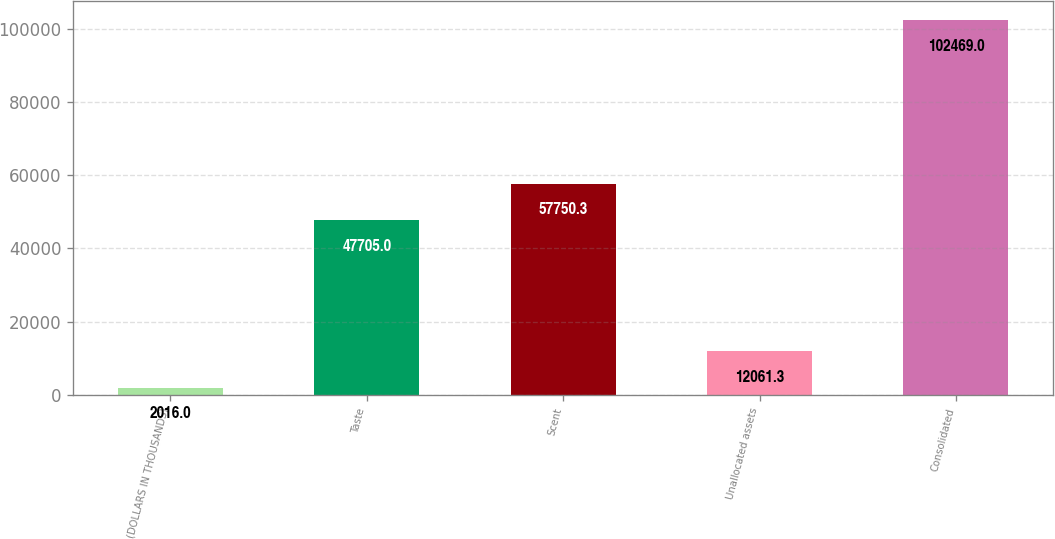<chart> <loc_0><loc_0><loc_500><loc_500><bar_chart><fcel>(DOLLARS IN THOUSANDS)<fcel>Taste<fcel>Scent<fcel>Unallocated assets<fcel>Consolidated<nl><fcel>2016<fcel>47705<fcel>57750.3<fcel>12061.3<fcel>102469<nl></chart> 